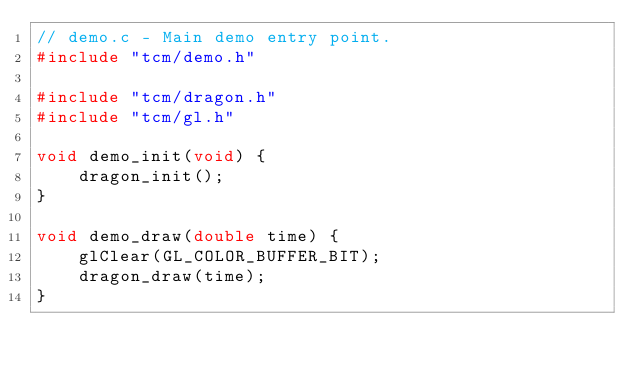Convert code to text. <code><loc_0><loc_0><loc_500><loc_500><_C_>// demo.c - Main demo entry point.
#include "tcm/demo.h"

#include "tcm/dragon.h"
#include "tcm/gl.h"

void demo_init(void) {
    dragon_init();
}

void demo_draw(double time) {
    glClear(GL_COLOR_BUFFER_BIT);
    dragon_draw(time);
}
</code> 